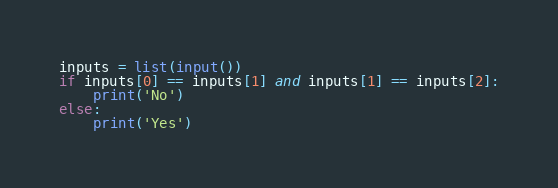Convert code to text. <code><loc_0><loc_0><loc_500><loc_500><_Python_>inputs = list(input())
if inputs[0] == inputs[1] and inputs[1] == inputs[2]:
	print('No')
else:
	print('Yes')</code> 